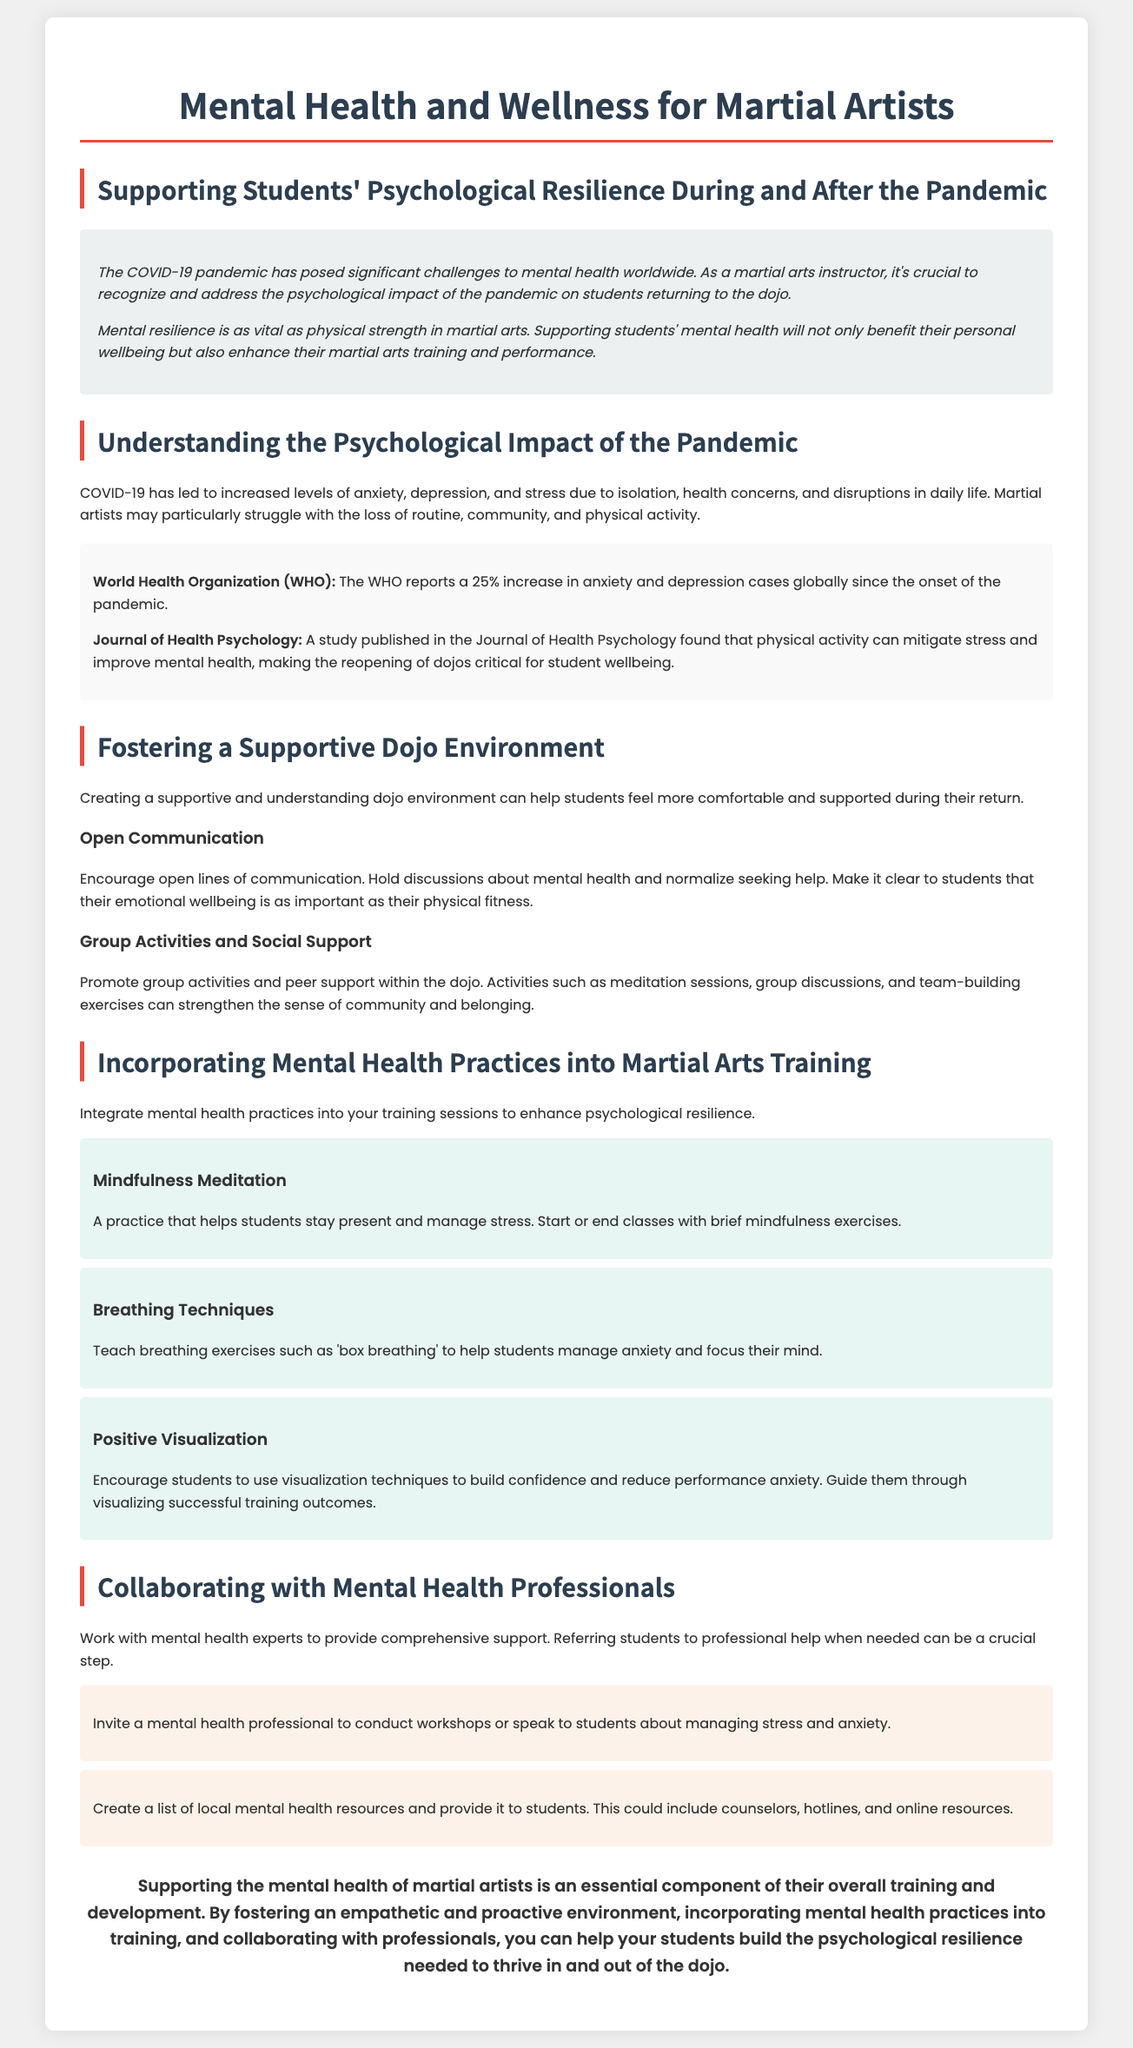What is the main focus of the whitepaper? The main focus is on psychological resilience for martial artists during and after the COVID-19 pandemic.
Answer: Psychological resilience What increase percentage in anxiety and depression cases does the WHO report? The WHO reports a 25% increase in anxiety and depression cases globally since the onset of the pandemic.
Answer: 25% Name one mental health practice suggested for martial arts training. The document suggests mindfulness meditation as one mental health practice to enhance psychological resilience.
Answer: Mindfulness meditation What type of environment should be fostered in the dojo? A supportive and understanding dojo environment should be fostered to help students feel more comfortable.
Answer: Supportive and understanding What is one benefit of physical activity mentioned in the document? Physical activity can mitigate stress and improve mental health, as stated in the document.
Answer: Mitigate stress Who should martial arts instructors collaborate with for better student support? Martial arts instructors should collaborate with mental health experts to provide comprehensive support for students.
Answer: Mental health experts What type of breathing exercise is mentioned in the techniques? The 'box breathing' technique is mentioned as a way to help students manage anxiety.
Answer: Box breathing What is a recommended activity to promote social support in the dojo? Group discussions are recommended activities to promote social support within the dojo.
Answer: Group discussions What does the conclusion emphasize the importance of? The conclusion emphasizes the importance of supporting the mental health of martial artists as essential to their overall training.
Answer: Supporting mental health 